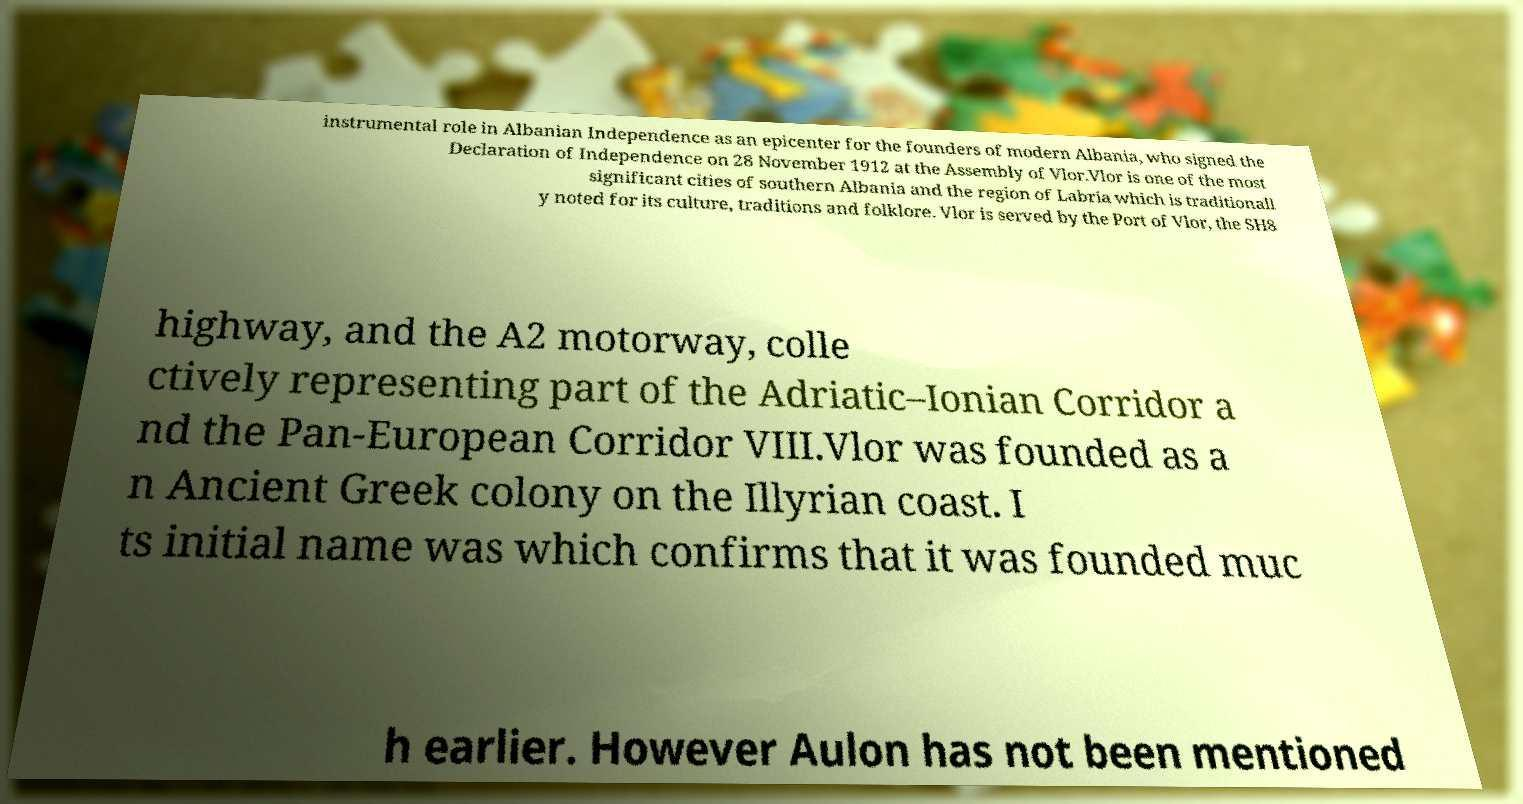Please read and relay the text visible in this image. What does it say? instrumental role in Albanian Independence as an epicenter for the founders of modern Albania, who signed the Declaration of Independence on 28 November 1912 at the Assembly of Vlor.Vlor is one of the most significant cities of southern Albania and the region of Labria which is traditionall y noted for its culture, traditions and folklore. Vlor is served by the Port of Vlor, the SH8 highway, and the A2 motorway, colle ctively representing part of the Adriatic–Ionian Corridor a nd the Pan-European Corridor VIII.Vlor was founded as a n Ancient Greek colony on the Illyrian coast. I ts initial name was which confirms that it was founded muc h earlier. However Aulon has not been mentioned 